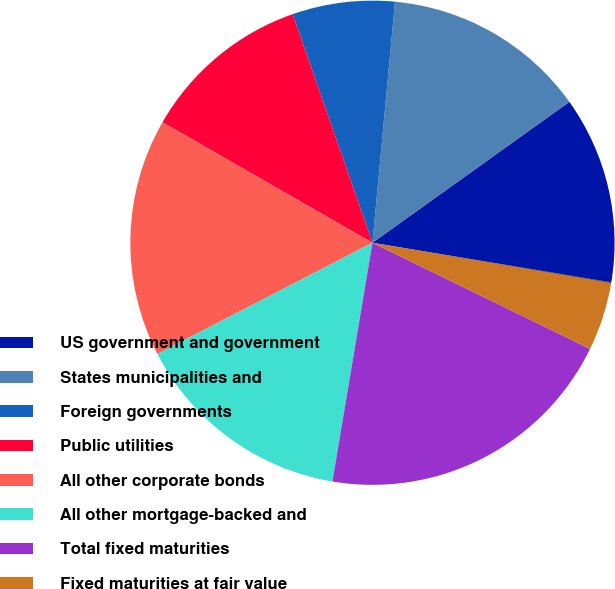<chart> <loc_0><loc_0><loc_500><loc_500><pie_chart><fcel>US government and government<fcel>States municipalities and<fcel>Foreign governments<fcel>Public utilities<fcel>All other corporate bonds<fcel>All other mortgage-backed and<fcel>Total fixed maturities<fcel>Fixed maturities at fair value<fcel>Industrial miscellaneous and<nl><fcel>12.5%<fcel>13.63%<fcel>6.83%<fcel>11.36%<fcel>15.89%<fcel>14.76%<fcel>20.42%<fcel>4.57%<fcel>0.04%<nl></chart> 